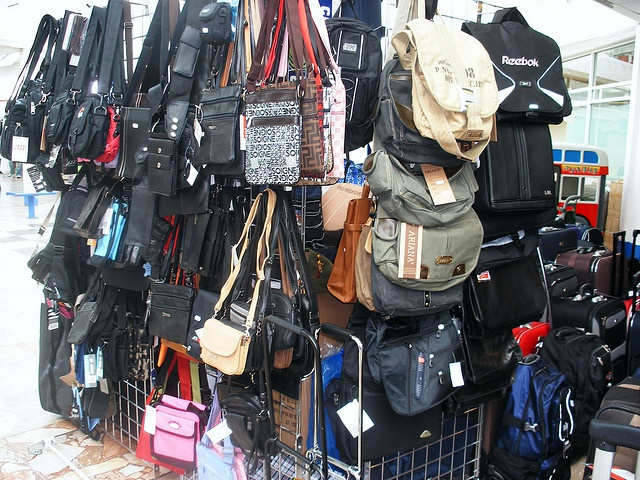Describe the objects in this image and their specific colors. I can see handbag in white, black, and gray tones, backpack in white, ivory, and tan tones, backpack in white, black, red, gray, and brown tones, backpack in white, black, navy, and blue tones, and backpack in white, gray, purple, and black tones in this image. 